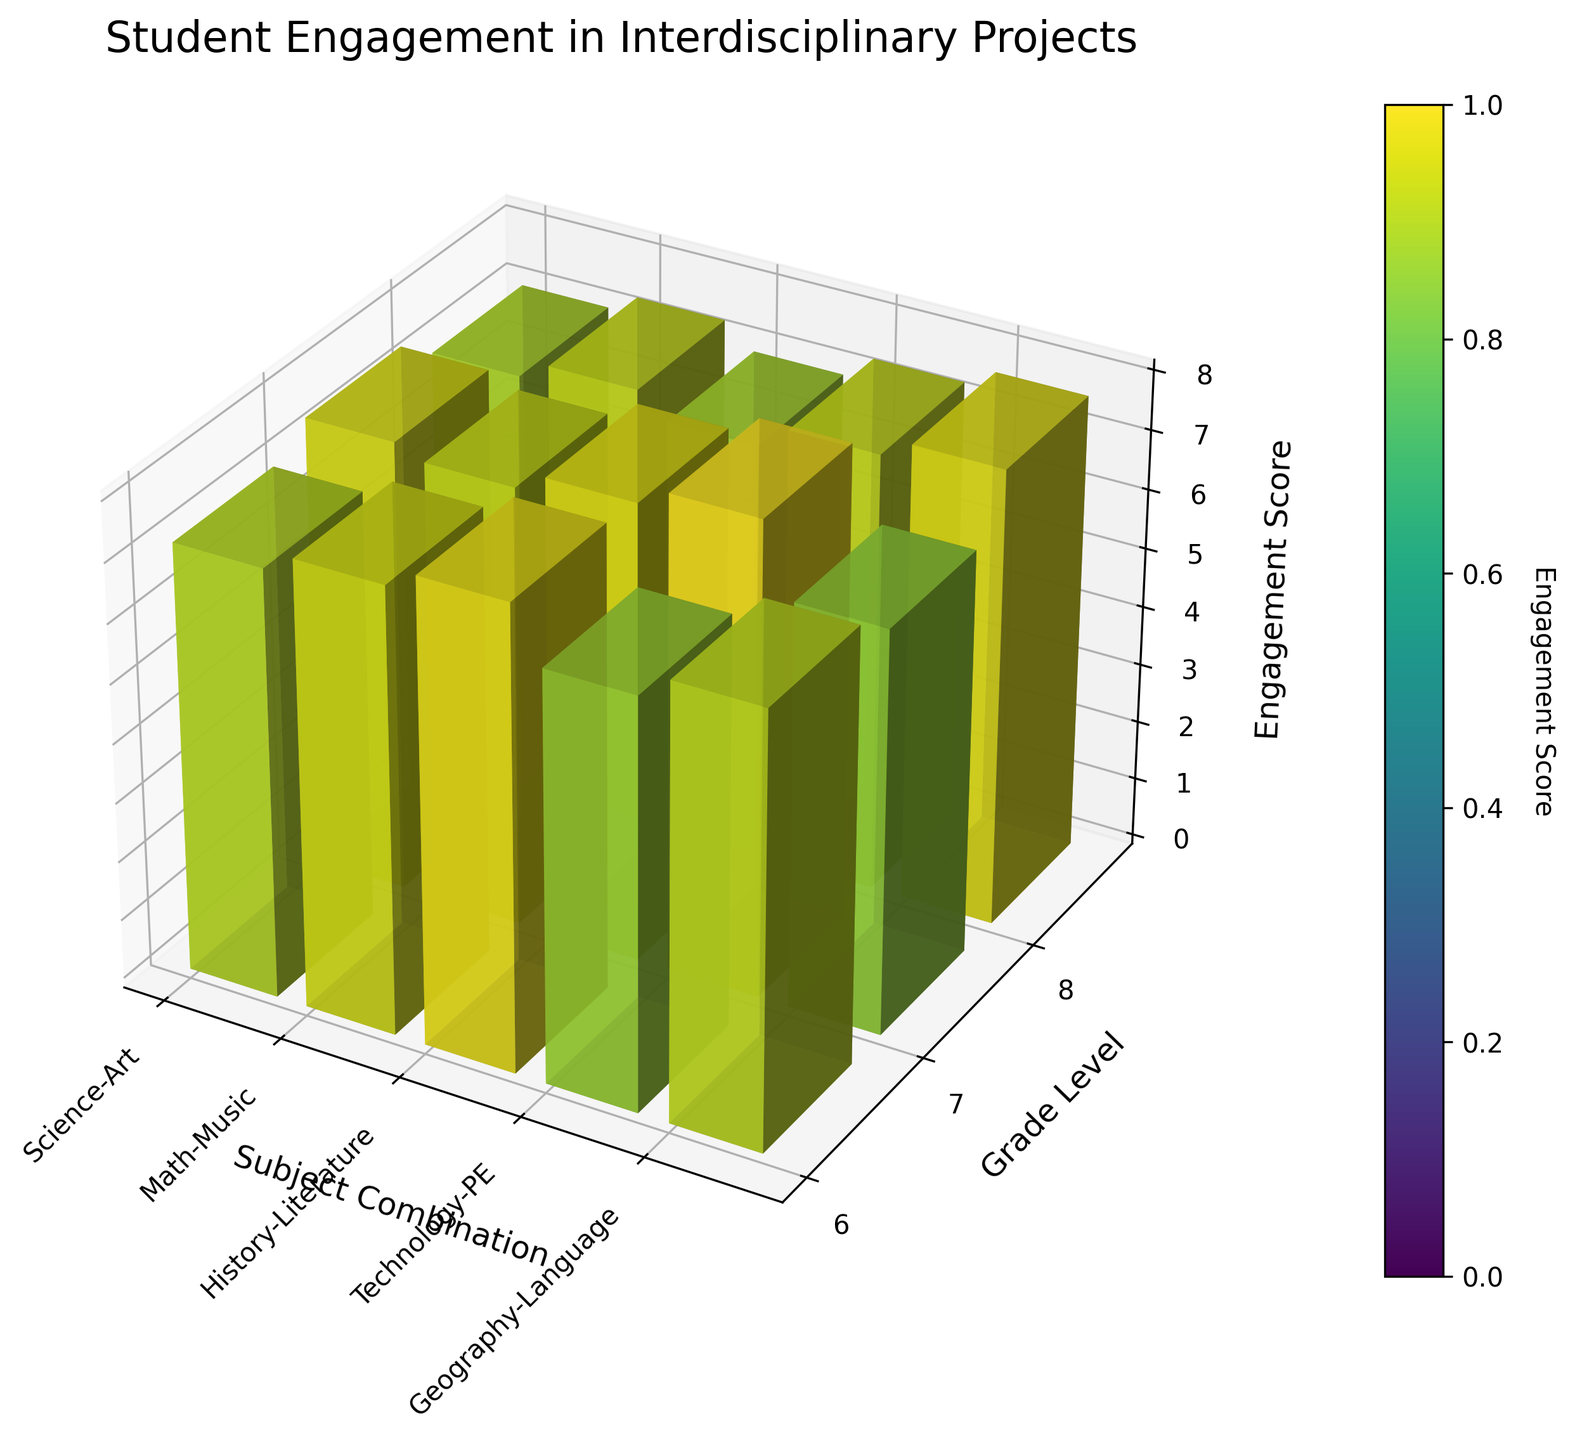What's the title of the plot? The title is usually displayed at the top of the figure. In this case, the title clearly indicates the subject of the plot, which is "Student Engagement in Interdisciplinary Projects."
Answer: Student Engagement in Interdisciplinary Projects What are the axes labels on this 3D bar plot? The axes labels provide context for the data being visualized. The x-axis represents the 'Subject Combination,' the y-axis represents the 'Grade Level,' and the z-axis represents the 'Engagement Score.'
Answer: Subject Combination, Grade Level, Engagement Score Which subject combination has the highest engagement score for 8th grade? First, identify the subject combinations along the x-axis and then look at the height of the bars at the 8th grade level (y-axis 8) to find which one reaches the highest on the z-axis. "History-Literature" has the highest bar indicating an engagement score of 8.0.
Answer: History-Literature What's the average engagement score for the subject combination "Math-Music"? To find the average, sum the engagement scores for "Math-Music" across all grade levels (6.9, 7.3, 7.6) and divide by the number of grades (3). (6.9 + 7.3 + 7.6) / 3 = 21.8 / 3 = 7.27
Answer: 7.27 Which grade level appears to be most engaged across all subject combinations? Find the average engagement score for each grade level across the various subject combinations and compare them. Grade 8 shows consistently higher engagement scores across all combinations, suggesting it's the most engaged.
Answer: 8th grade How does the engagement in "Science-Art" change from grade 6 to grade 8? Compare the height of the bars for "Science-Art" across grades 6, 7, and 8. The engagement score increases from 7.2 in grade 6 to 7.5 in grade 7 and finally to 7.8 in grade 8.
Answer: It increases Which subject combinations have engagement scores greater than 7.5 for 7th grade? Look at the bars corresponding to the 7th grade level. "Science-Art" (7.5), "History-Literature" (7.7), and "Geography-Language" (7.4) are relevant. However, only "History-Literature" and "Science-Art" have scores greater than 7.5.
Answer: History-Literature, Science-Art What's the general trend of engagement in "Technology-PE" across different grade levels? Observe the bars for "Technology-PE" across grades 6, 7, and 8. The engagement scores increase from 6.8 in grade 6 to 7.1 in grade 7 and then to 7.4 in grade 8, indicating a rising trend.
Answer: Increasing trend Compare the engagement scores for "Geography-Language" in grade 6 and grade 8. Check the heights of the bars for "Geography-Language" at grades 6 and 8. The scores are 7.0 for grade 6 and 7.7 for grade 8, showing an increase from grade 6 to grade 8.
Answer: Increased 